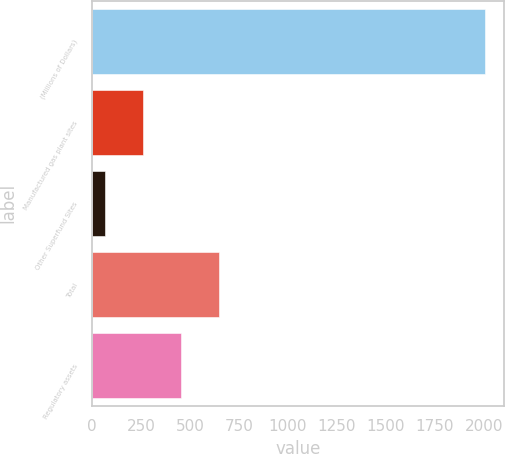<chart> <loc_0><loc_0><loc_500><loc_500><bar_chart><fcel>(Millions of Dollars)<fcel>Manufactured gas plant sites<fcel>Other Superfund Sites<fcel>Total<fcel>Regulatory assets<nl><fcel>2005<fcel>259<fcel>65<fcel>647<fcel>453<nl></chart> 